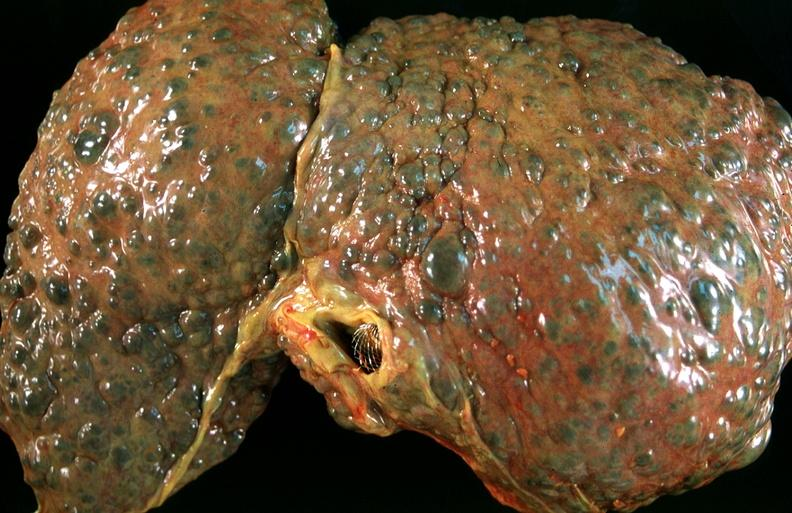s glomerulosa present?
Answer the question using a single word or phrase. No 